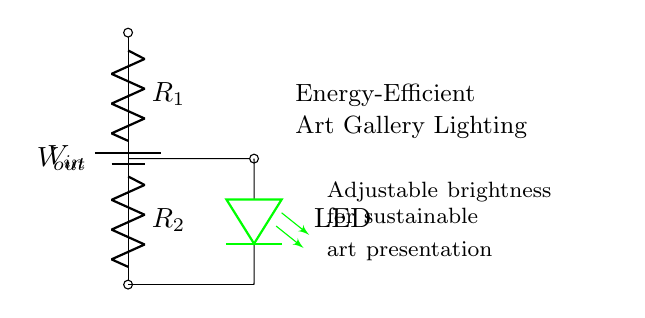What is the input voltage in this circuit? The input voltage, represented by V_{in}, is the source voltage provided at the top of the circuit, connected to the battery. Without specific values given, we refer to it conceptually as V_{in}.
Answer: V_{in} What is the purpose of the resistors R1 and R2? R1 and R2 are used in the voltage divider configuration to set the output voltage (V_{out}) based on the division of input voltage (V_{in}) across them, which adjusts the brightness of the LED.
Answer: To control voltage output What is the LED's color in this circuit? The LED is specified as green in color, indicated in the circuit diagram next to the LED symbol.
Answer: Green How is the output voltage affected by the resistor values? The output voltage (V_{out}) depends on the values of the resistors R1 and R2 as per the voltage divider rule, where V_{out} is given by the ratio of R2 to the total resistance (R1 + R2) multiplied by V_{in}. Therefore, changing R1 and R2 will change V_{out} and thus the LED brightness.
Answer: It varies with resistor values What type of circuit is depicted here? The circuit is a voltage divider, as indicated by its configuration with resistors R1 and R2 arranged in series, allowing for control of the output voltage for the LED.
Answer: Voltage divider What happens to the LED brightness when R2 is increased? Increasing R2 will result in a higher output voltage (V_{out}), which means more current flows through the LED, resulting in increased brightness.
Answer: Increases brightness What is the significance of adjustable brightness in this circuit? Adjustable brightness allows for the LED's intensity to be tailored to enhance the presentation of art in an energy-efficient manner, promoting sustainability in lighting design.
Answer: Enhances sustainable art presentation 